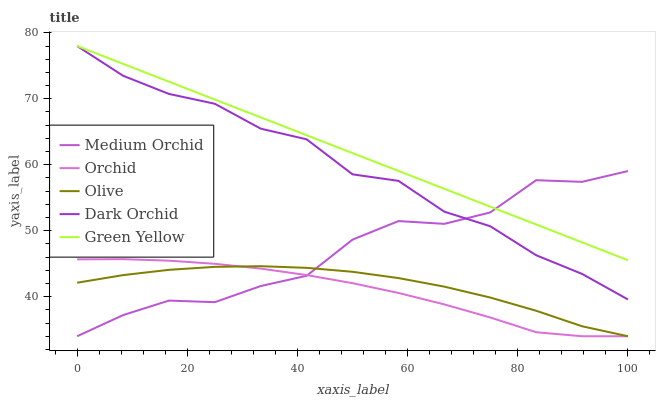Does Orchid have the minimum area under the curve?
Answer yes or no. Yes. Does Green Yellow have the maximum area under the curve?
Answer yes or no. Yes. Does Medium Orchid have the minimum area under the curve?
Answer yes or no. No. Does Medium Orchid have the maximum area under the curve?
Answer yes or no. No. Is Green Yellow the smoothest?
Answer yes or no. Yes. Is Medium Orchid the roughest?
Answer yes or no. Yes. Is Medium Orchid the smoothest?
Answer yes or no. No. Is Green Yellow the roughest?
Answer yes or no. No. Does Olive have the lowest value?
Answer yes or no. Yes. Does Green Yellow have the lowest value?
Answer yes or no. No. Does Dark Orchid have the highest value?
Answer yes or no. Yes. Does Medium Orchid have the highest value?
Answer yes or no. No. Is Orchid less than Dark Orchid?
Answer yes or no. Yes. Is Dark Orchid greater than Olive?
Answer yes or no. Yes. Does Dark Orchid intersect Green Yellow?
Answer yes or no. Yes. Is Dark Orchid less than Green Yellow?
Answer yes or no. No. Is Dark Orchid greater than Green Yellow?
Answer yes or no. No. Does Orchid intersect Dark Orchid?
Answer yes or no. No. 